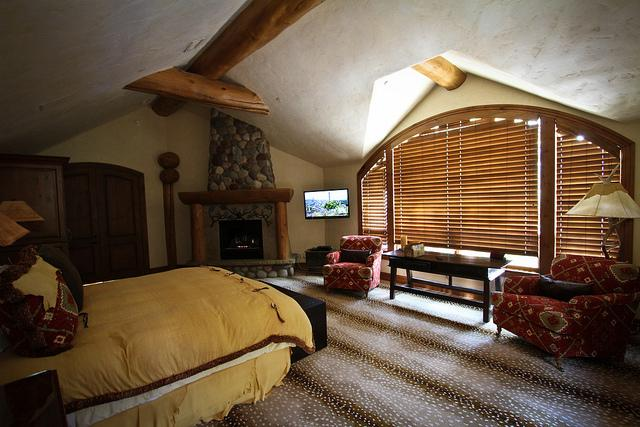What is the rectangular image in the corner of the room? Please explain your reasoning. television. The image is the tv. 